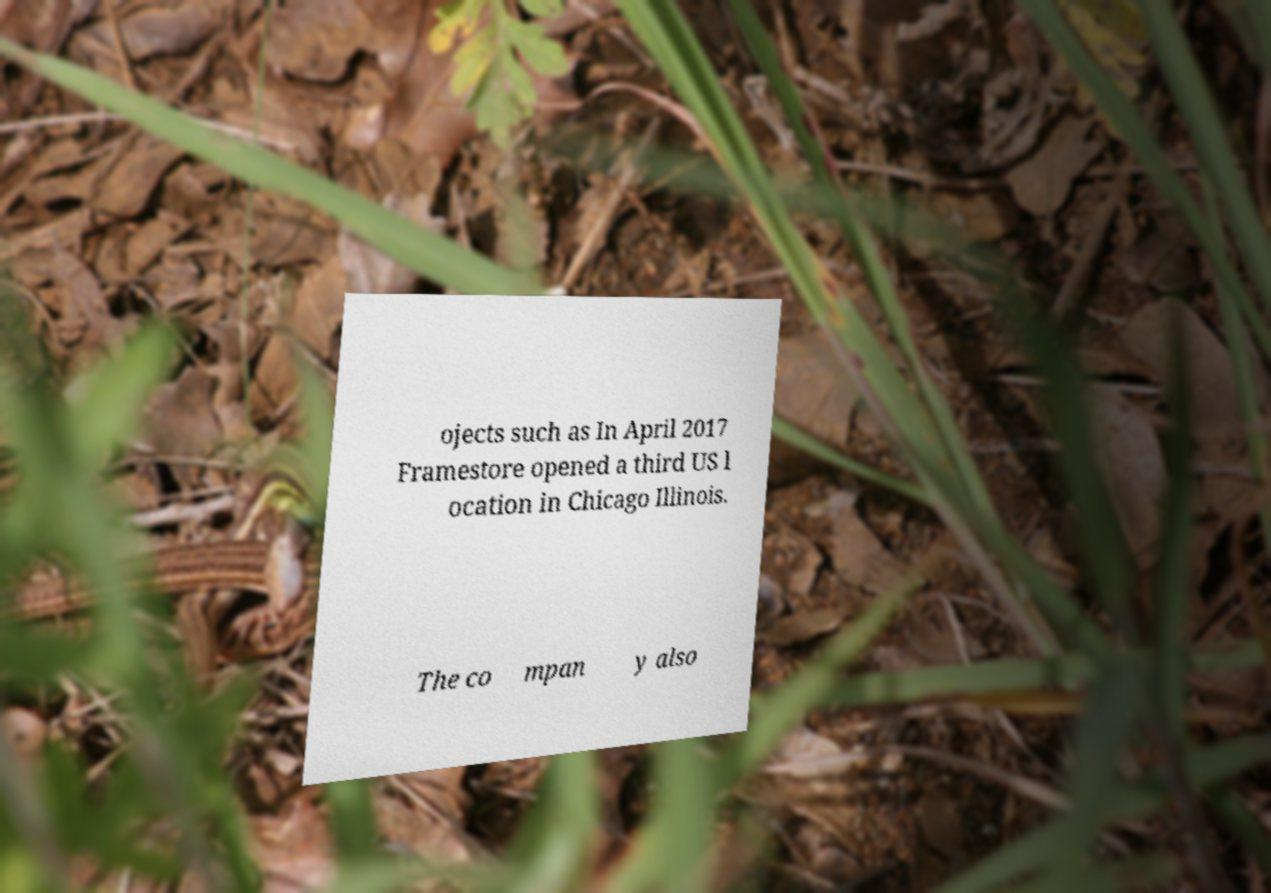Could you extract and type out the text from this image? ojects such as In April 2017 Framestore opened a third US l ocation in Chicago Illinois. The co mpan y also 